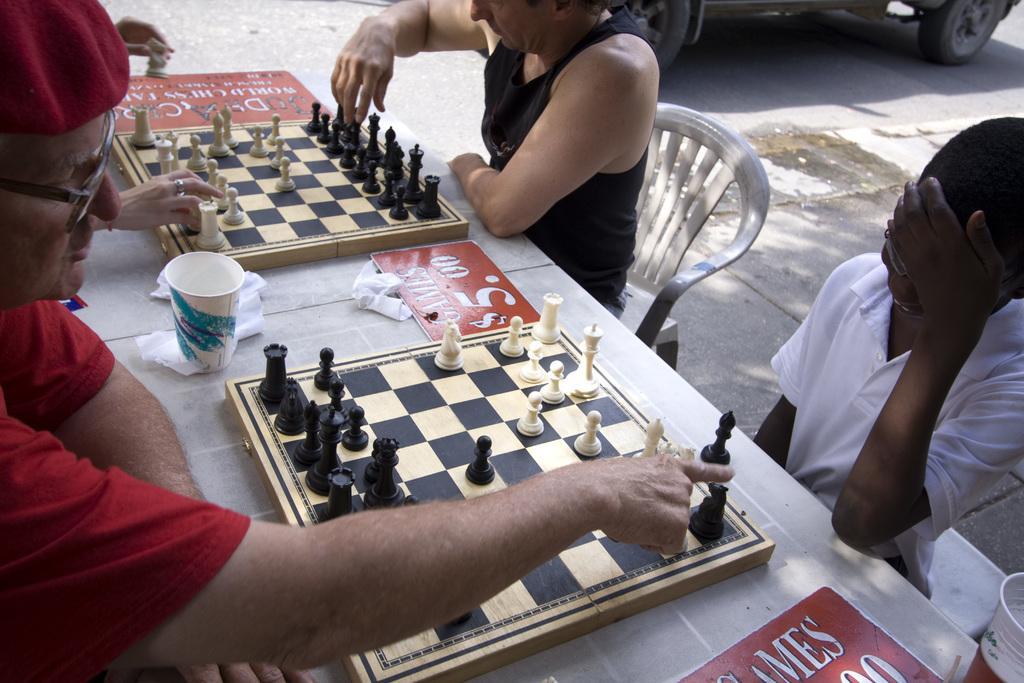Please provide a concise description of this image. In this image there are three persons sitting in front of table and playing chess. To the left the man is wearing a red colored shirt and red cap with spectacles. To the right the man is wearing black colored sleeveless. And a boy is sitting to the right of the image. In the background there is a vehicle standing. 